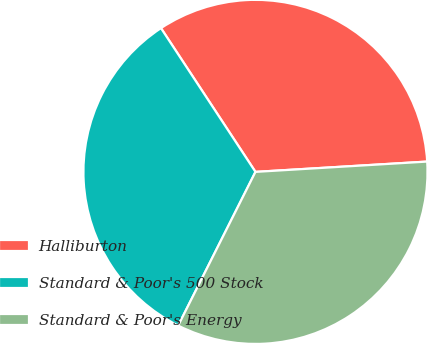Convert chart. <chart><loc_0><loc_0><loc_500><loc_500><pie_chart><fcel>Halliburton<fcel>Standard & Poor's 500 Stock<fcel>Standard & Poor's Energy<nl><fcel>33.3%<fcel>33.33%<fcel>33.37%<nl></chart> 